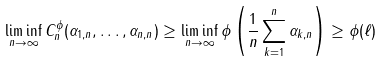Convert formula to latex. <formula><loc_0><loc_0><loc_500><loc_500>\liminf _ { n \to \infty } C _ { n } ^ { \phi } ( \alpha _ { 1 , n } , \dots , \alpha _ { n , n } ) \geq \liminf _ { n \to \infty } \phi \left ( \frac { 1 } { n } \sum _ { k = 1 } ^ { n } \alpha _ { k , n } \right ) \geq \phi ( \ell )</formula> 